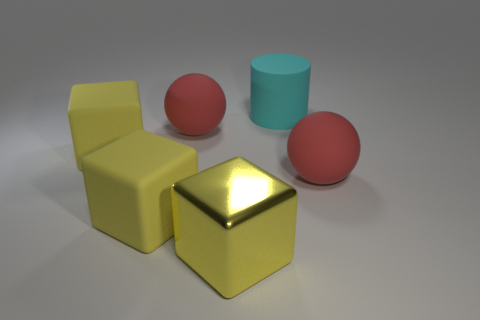What is the shape of the big rubber thing that is both in front of the large cylinder and on the right side of the shiny thing?
Offer a terse response. Sphere. How many big things are gray balls or blocks?
Your answer should be very brief. 3. What material is the cyan cylinder?
Your answer should be very brief. Rubber. What number of other objects are the same shape as the big cyan matte thing?
Provide a succinct answer. 0. The cylinder has what size?
Keep it short and to the point. Large. There is a thing that is both on the right side of the large yellow metallic thing and in front of the cyan object; how big is it?
Your answer should be compact. Large. What shape is the big red thing that is left of the big cyan thing?
Your response must be concise. Sphere. Are the cylinder and the big sphere left of the yellow shiny thing made of the same material?
Provide a succinct answer. Yes. Do the big yellow metal object and the cyan object have the same shape?
Keep it short and to the point. No. There is a big rubber thing that is to the right of the yellow shiny object and in front of the cylinder; what color is it?
Provide a short and direct response. Red. 